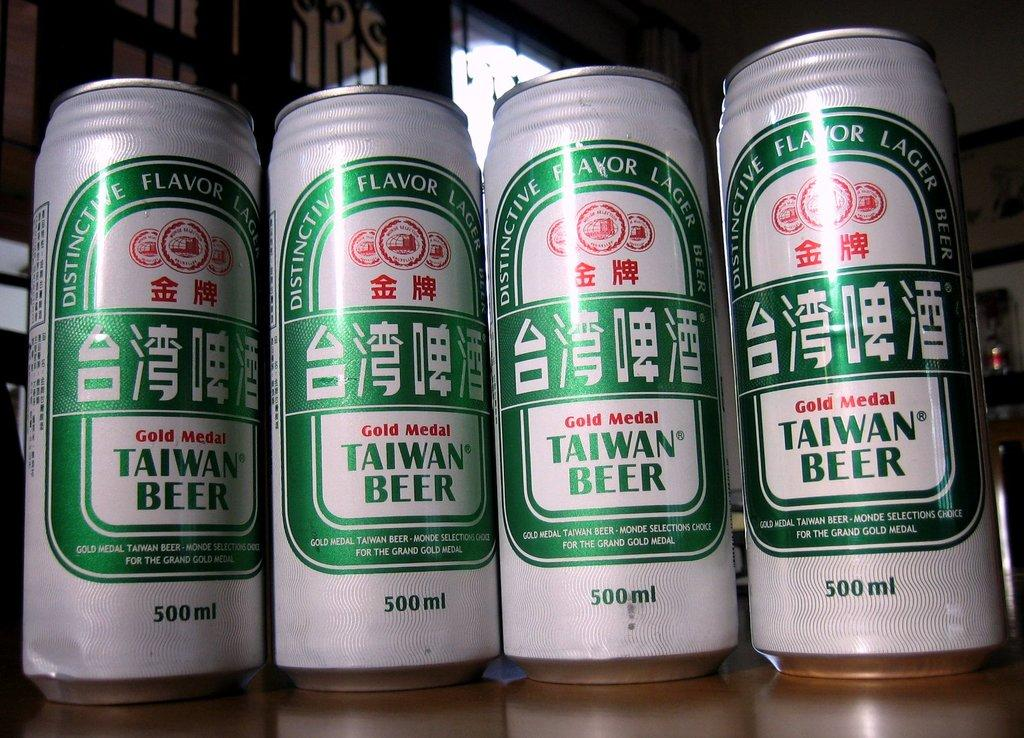<image>
Present a compact description of the photo's key features. taiwan beer is lined up with three other taiwan beers 